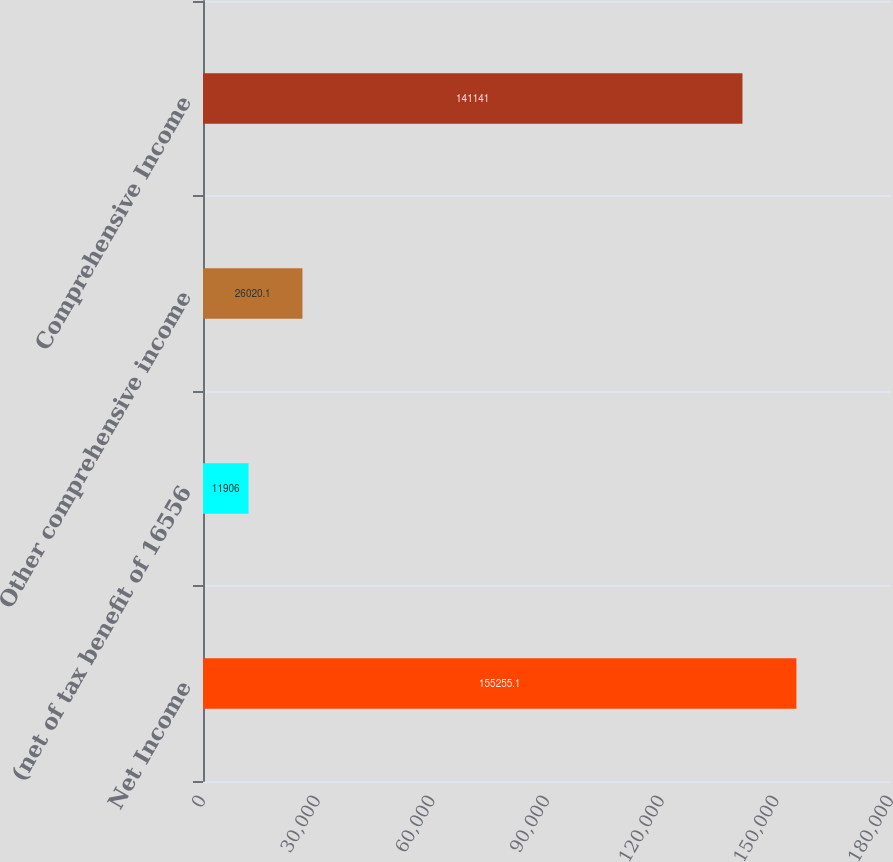Convert chart to OTSL. <chart><loc_0><loc_0><loc_500><loc_500><bar_chart><fcel>Net Income<fcel>(net of tax benefit of 16556<fcel>Other comprehensive income<fcel>Comprehensive Income<nl><fcel>155255<fcel>11906<fcel>26020.1<fcel>141141<nl></chart> 